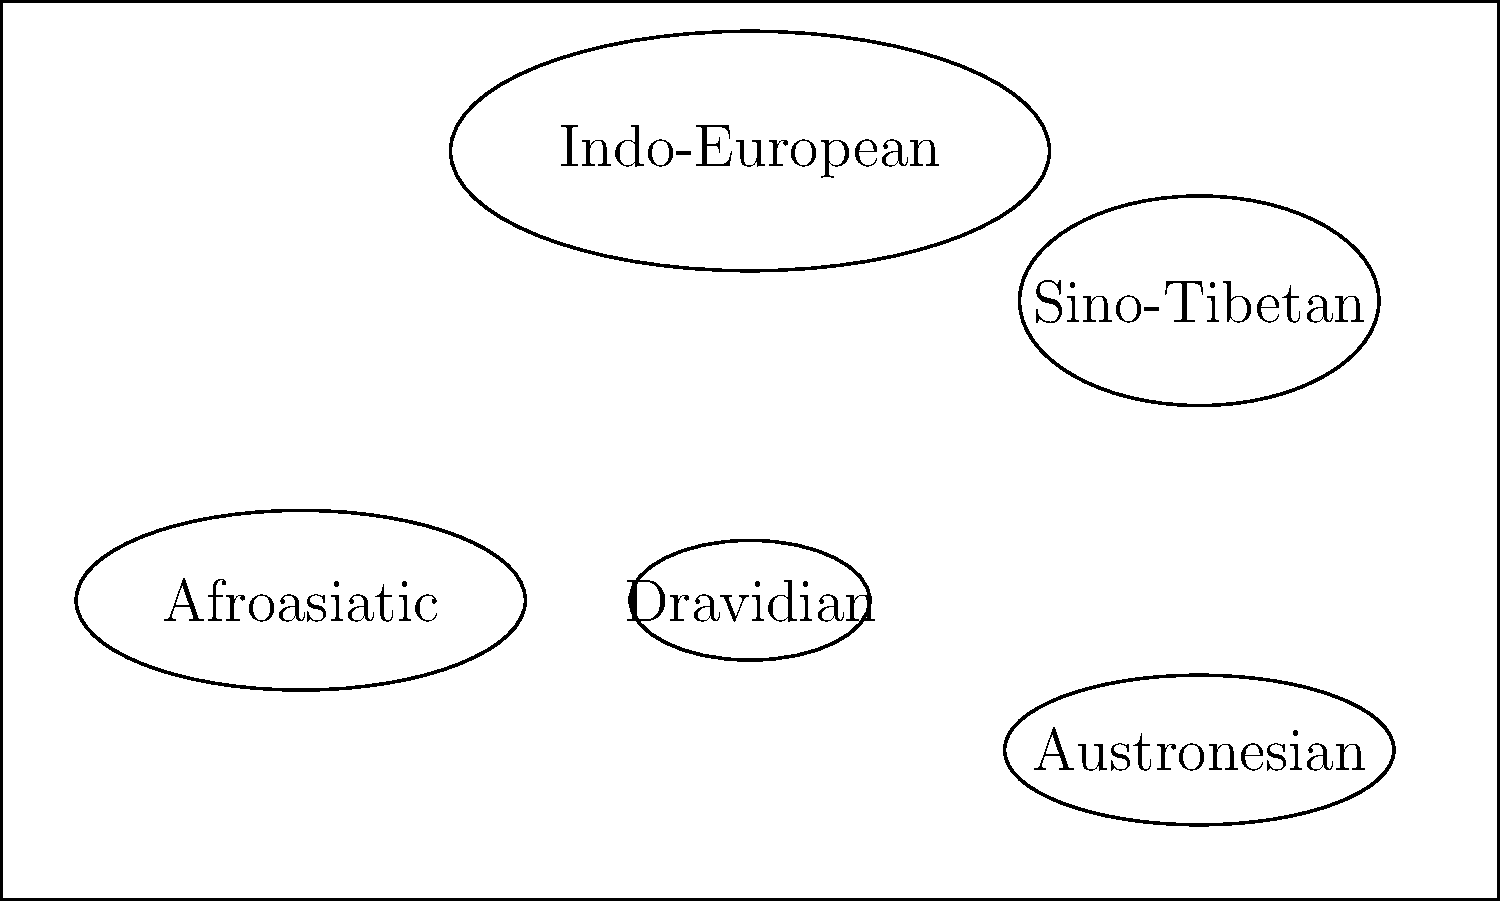Based on the world map representation of ancient language families, which family appears to have the most extensive distribution? To determine which ancient language family has the most extensive distribution, we need to analyze the relative sizes and positions of the ellipses representing each family on the simplified world map:

1. Indo-European: This family is represented by the largest ellipse, positioned centrally and spanning a significant portion of the map. Its size suggests a wide distribution across multiple continents.

2. Afroasiatic: Represented by a medium-sized ellipse in the lower-left quadrant, indicating a significant but more localized distribution, likely in Africa and parts of the Middle East.

3. Sino-Tibetan: A medium-sized ellipse in the upper-right quadrant, suggesting a considerable distribution in East Asia.

4. Austronesian: A medium-sized ellipse in the lower-right quadrant, indicating a spread across islands and coastal regions, likely in Southeast Asia and the Pacific.

5. Dravidian: The smallest ellipse, centrally located in the lower half, suggesting a more limited distribution, probably in South Asia.

Comparing these representations, the Indo-European family clearly has the largest ellipse and most central position, indicating the most extensive distribution across the ancient world.
Answer: Indo-European 